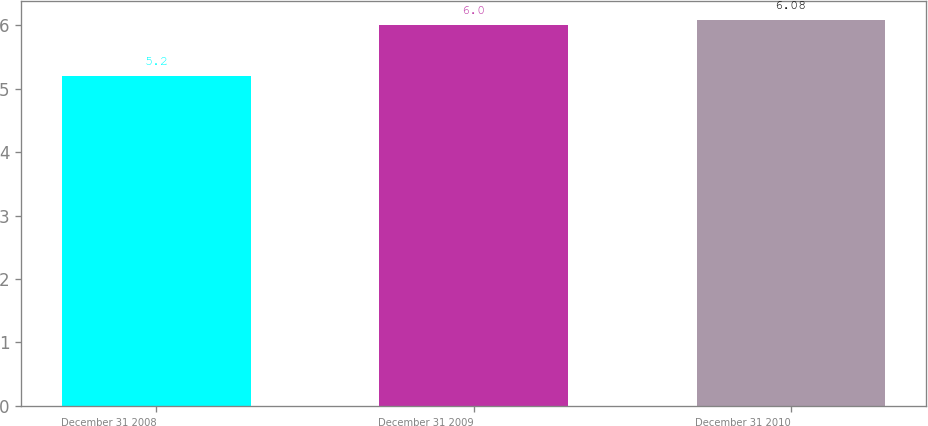<chart> <loc_0><loc_0><loc_500><loc_500><bar_chart><fcel>December 31 2008<fcel>December 31 2009<fcel>December 31 2010<nl><fcel>5.2<fcel>6<fcel>6.08<nl></chart> 